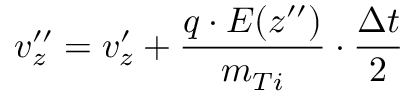Convert formula to latex. <formula><loc_0><loc_0><loc_500><loc_500>v _ { z } ^ { \prime \prime } = v _ { z } ^ { \prime } + \frac { q \cdot E ( z ^ { \prime \prime } ) } { m _ { T i } } \cdot \frac { \Delta t } { 2 }</formula> 